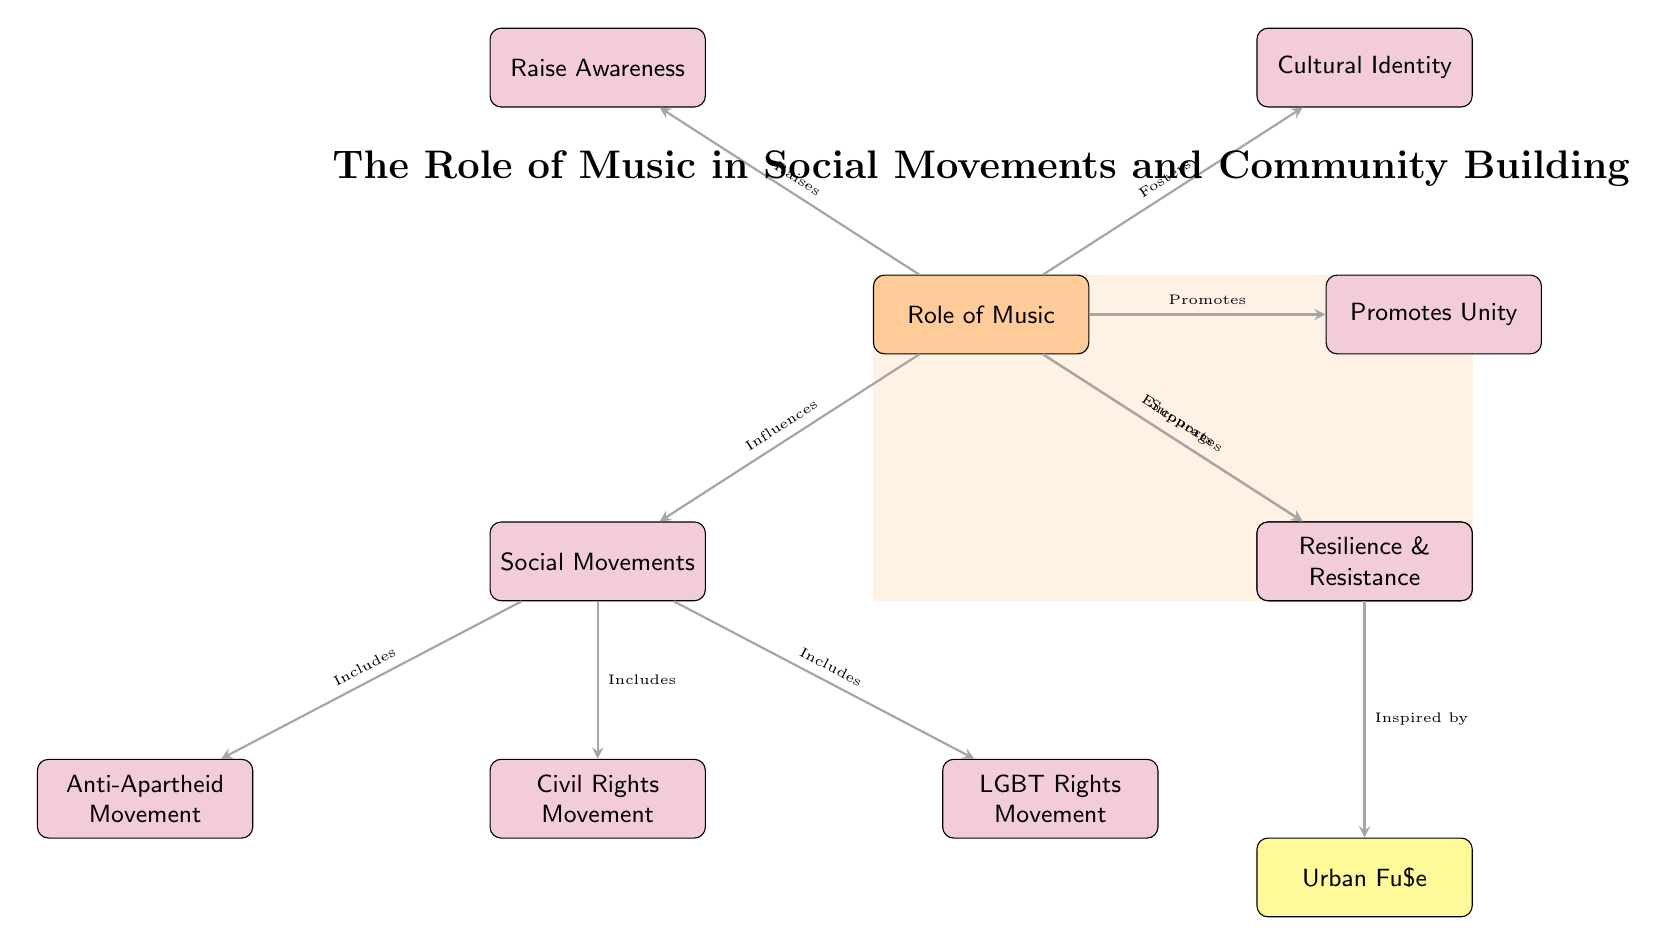What is the main role of music according to the diagram? The diagram identifies the central role of music as influencing social movements and supporting community building, as indicated in the arrows leading to both nodes.
Answer: Influences social movements and supports community building How many social movements are included in the diagram? Three social movements are explicitly listed in the diagram: the Civil Rights Movement, Anti-Apartheid Movement, and LGBT Rights Movement. The diagram effectively demonstrates the relationship between music and these movements.
Answer: Three What movement is specifically inspired by modern artists? The diagram shows that Urban Fu$e is inspired by community building, which connects directly to the role of music in social movements.
Answer: Community building What aspect does music promote according to the diagram? The diagram indicates that music promotes unity, as directly labeled by the arrow leading from music to the unity node.
Answer: Unity How does music encourage social movements to raise awareness? The arrow from music to the awareness node shows that one function of music is to raise awareness, which is essential for social movements by conveying messages and mobilizing support.
Answer: Raises awareness Which node is associated with cultural identity in the context of music? The diagram clearly connects the concept of cultural identity to music by drawing an arrow from music to the identity node, indicating its significance.
Answer: Cultural identity What type of resistance does music encourage in movements? The diagram identifies resilience and resistance as vital themes associated with music, demonstrating music's role in empowering social movements to persist through challenges.
Answer: Resilience & resistance What are the two primary functions of music detailed in the diagram? The diagram illustrates that music influences social movements and supports community building, emphasizing these two critical functions in the social context.
Answer: Influences social movements and supports community building Which node comes directly under the community building node and represents a modern artist? The modern artist node, Urban Fu$e, is positioned directly below the community building node, indicating its relevance to this theme.
Answer: Urban Fu$e 